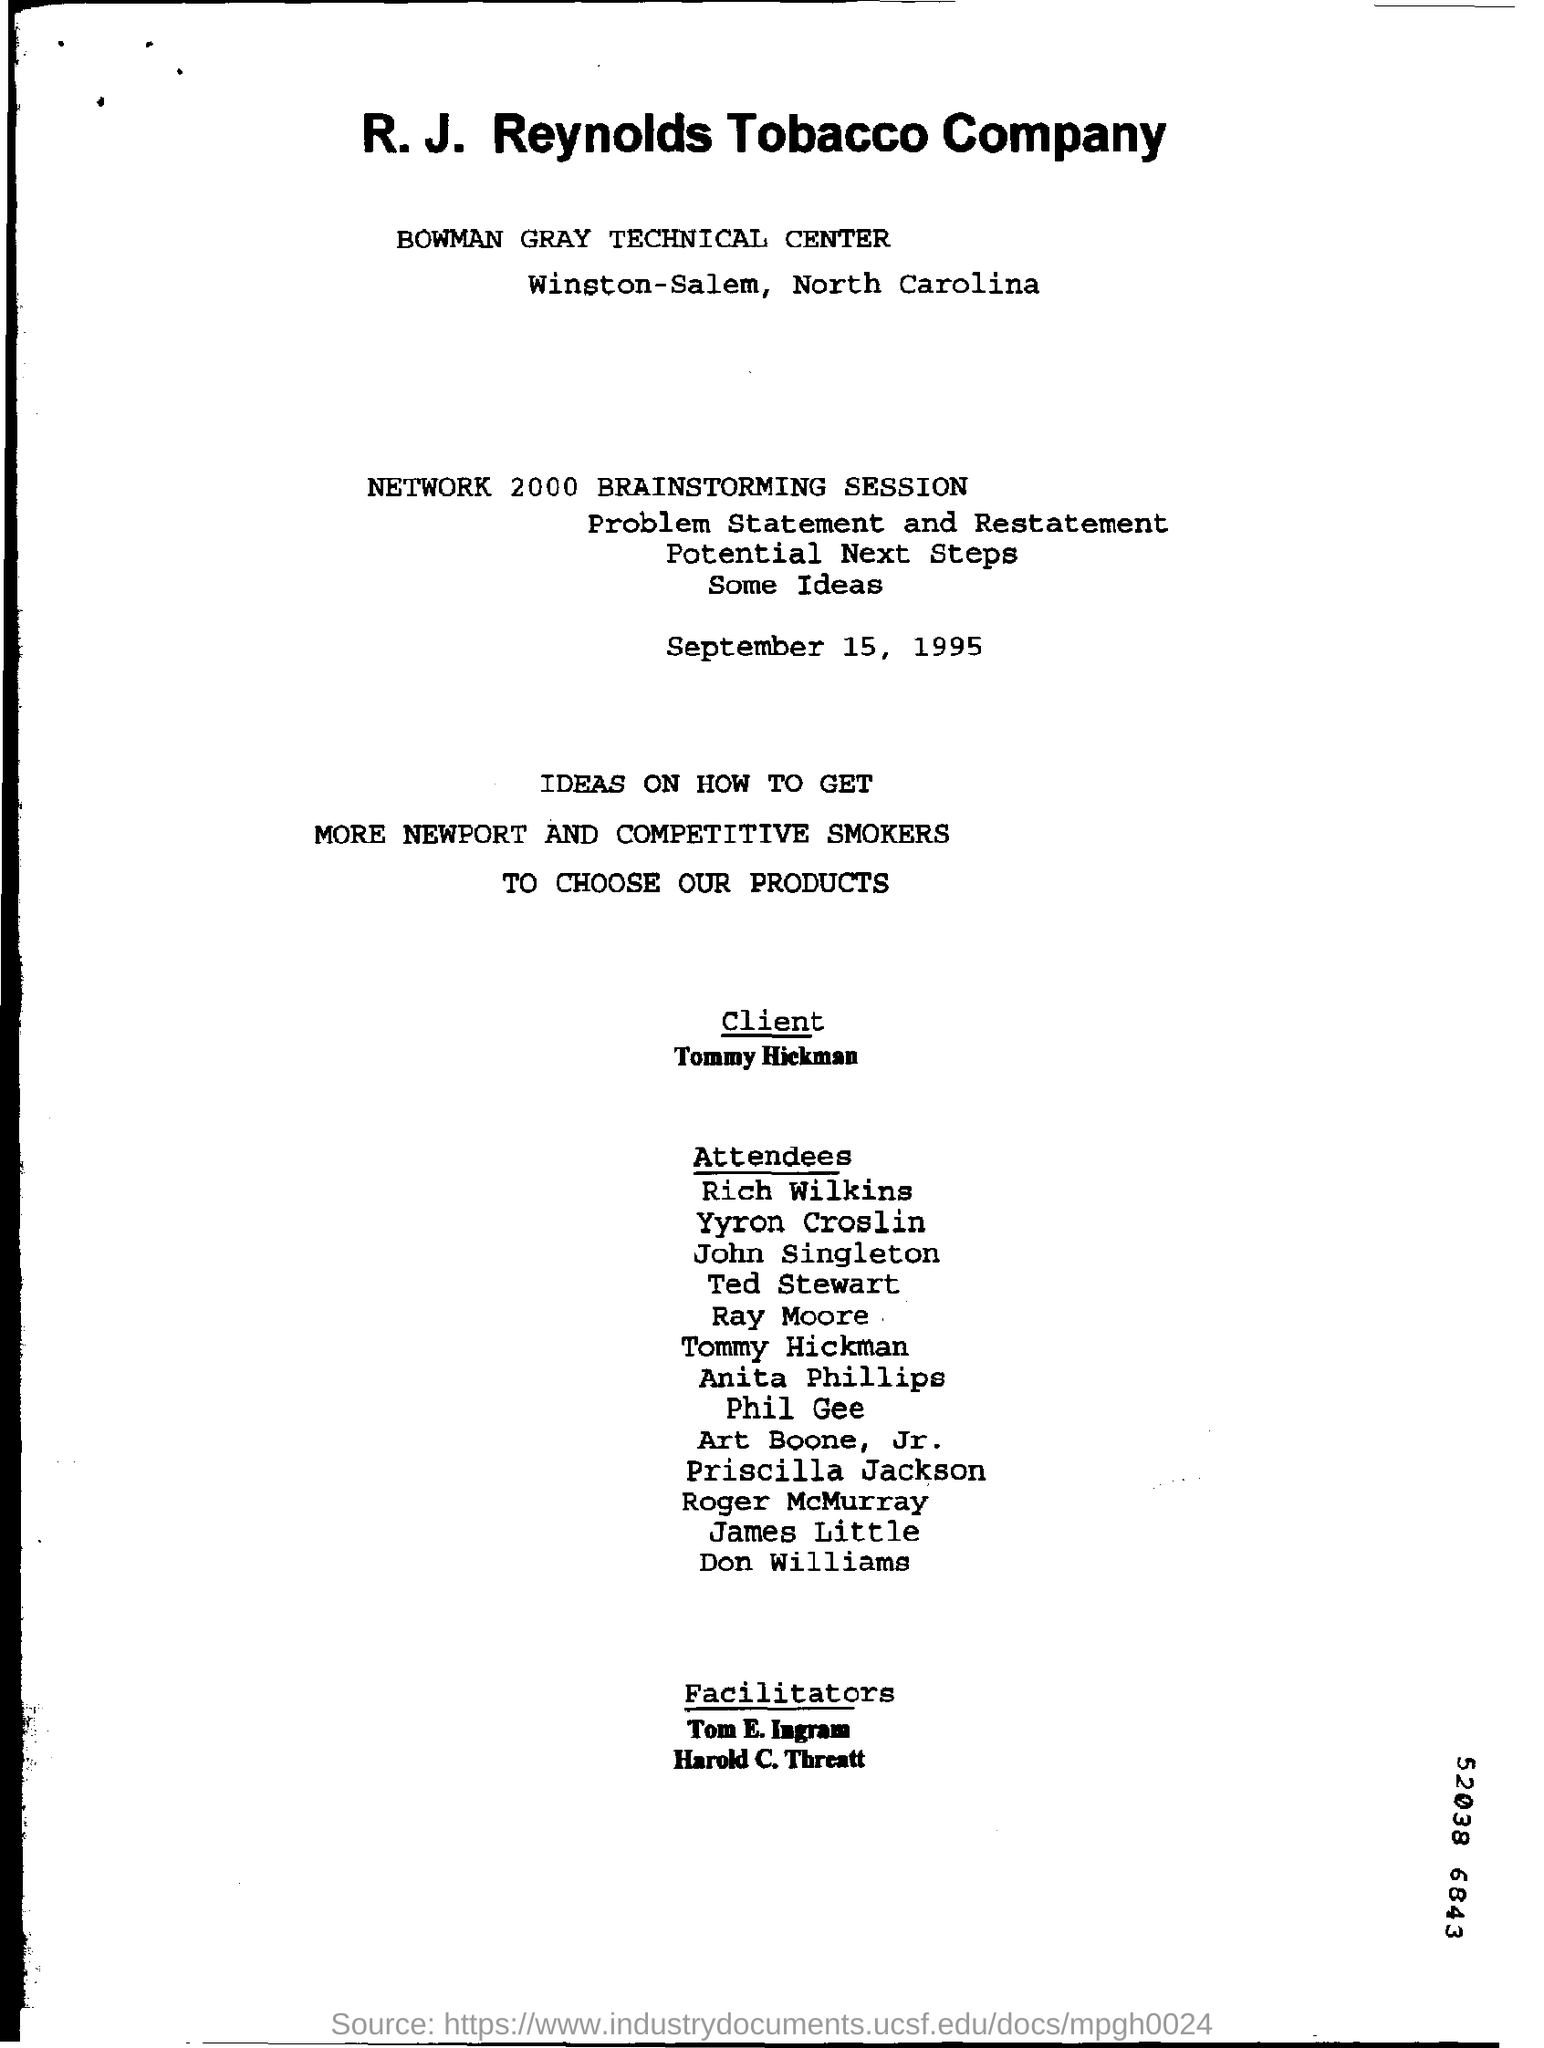Which company's name is given in the title?
Offer a terse response. R. J. Reynolds Tobacco Company. Where is the bowman gray technical center?
Make the answer very short. Winston-Salem, North Carolina. What is the date on which this brainstorming session is held?
Ensure brevity in your answer.  September 15, 1995. 